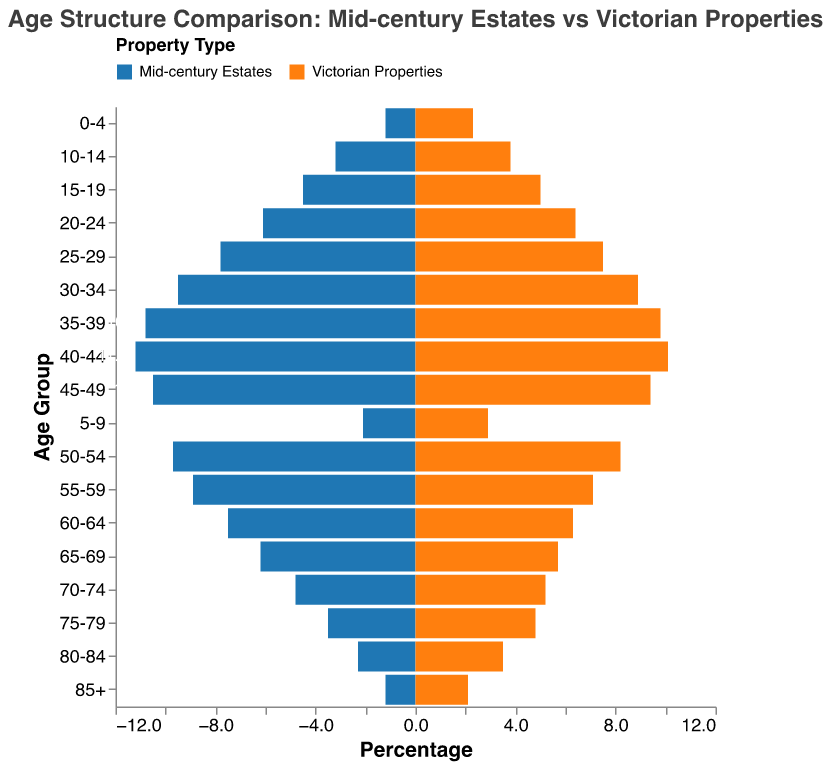What is the title of the figure? The title of the figure can be found at the top of the plot.
Answer: Age Structure Comparison: Mid-century Estates vs Victorian Properties How are the age groups structured on the y-axis? The y-axis lists the age groups from youngest at the bottom to oldest at the top.
Answer: The age groups are structured from 0-4 to 85+ What color represents mid-century estates in the plot? The legend on the plot indicates the color used for mid-century estates.
Answer: Blue Which property type has a higher percentage of residents aged 85+? The plot shows the data for the 85+ age group for both property types. The Victorian properties bar is longer.
Answer: Victorian Properties What's the percentage difference between the age group 55-59 in mid-century estates and Victorian properties? Refer to the values for the 55-59 age group in both property types and subtract the smaller value from the larger one.
Answer: 1.8% Which property type has more residents aged below 10? Check the values for the age groups 0-4 and 5-9 for both property types. Victorian properties have higher percentages in both age groups.
Answer: Victorian Properties In which age group do mid-century estates have the highest percentage? Find the highest bar length or value for mid-century estates among all age groups.
Answer: 40-44 What percentage of residents are aged 70-74 in mid-century estates? Look for the 70-74 age group on the y-axis and find the corresponding value for mid-century estates.
Answer: 4.8% Which age group has the smallest percentage difference between the two property types? Compare the differences in percentages across all age groups and find the smallest difference.
Answer: 25-29 Compare the total percentage of residents aged 60+ between mid-century estates and Victorian properties. Sum the percentages of all age groups 60 and above for each property type and compare. For mid-century estates: 1.2 + 2.3 + 3.5 + 4.8 + 6.2 + 7.5 = 25.5; for Victorian properties: 2.1 + 3.5 + 4.8 + 5.2 + 5.7 + 6.3 = 27.6.
Answer: Victorian Properties 